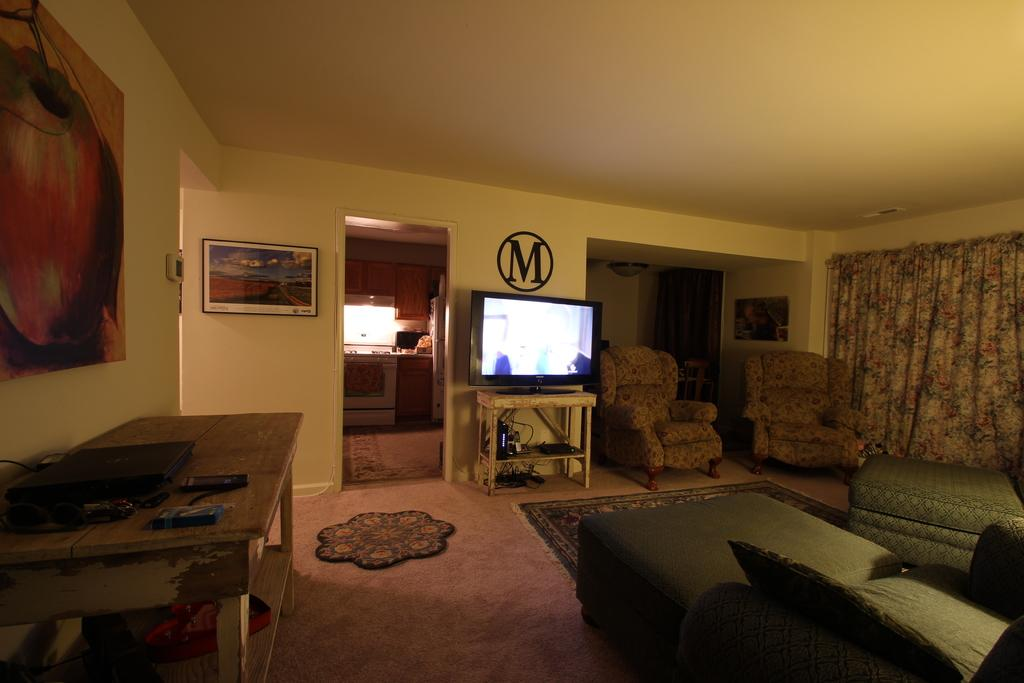What type of furniture is present in the image? There are sofa chairs and sofa beds in the image. What type of entertainment device is in the image? There is a television in the image. What is the purpose of the table in the image? The table is used for placing items on it. What can be seen on the walls in the image? There are frames on the walls and a black color logo. What type of riddle is written on the sofa chair in the image? There is no riddle written on the sofa chair or any other item in the image. Can you tell me how many grapes are on the table in the image? There are no grapes present on the table or anywhere else in the image. 